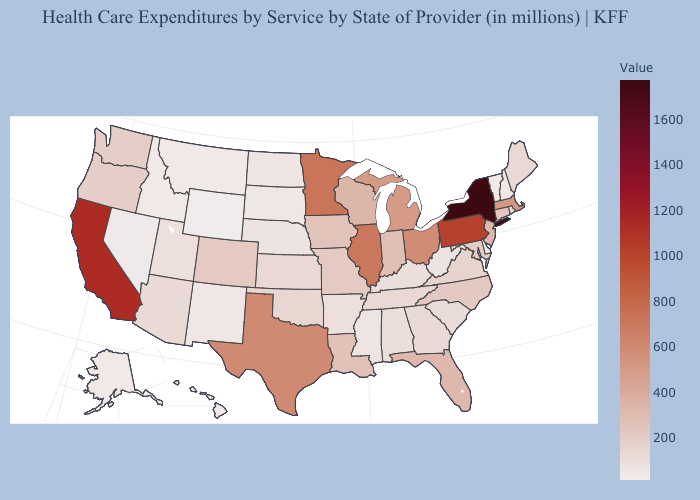Which states have the lowest value in the West?
Quick response, please. Wyoming. Among the states that border New Hampshire , does Massachusetts have the highest value?
Concise answer only. Yes. Is the legend a continuous bar?
Short answer required. Yes. Does New York have the highest value in the Northeast?
Keep it brief. Yes. Does West Virginia have a higher value than Michigan?
Answer briefly. No. Among the states that border Iowa , which have the lowest value?
Quick response, please. South Dakota. 